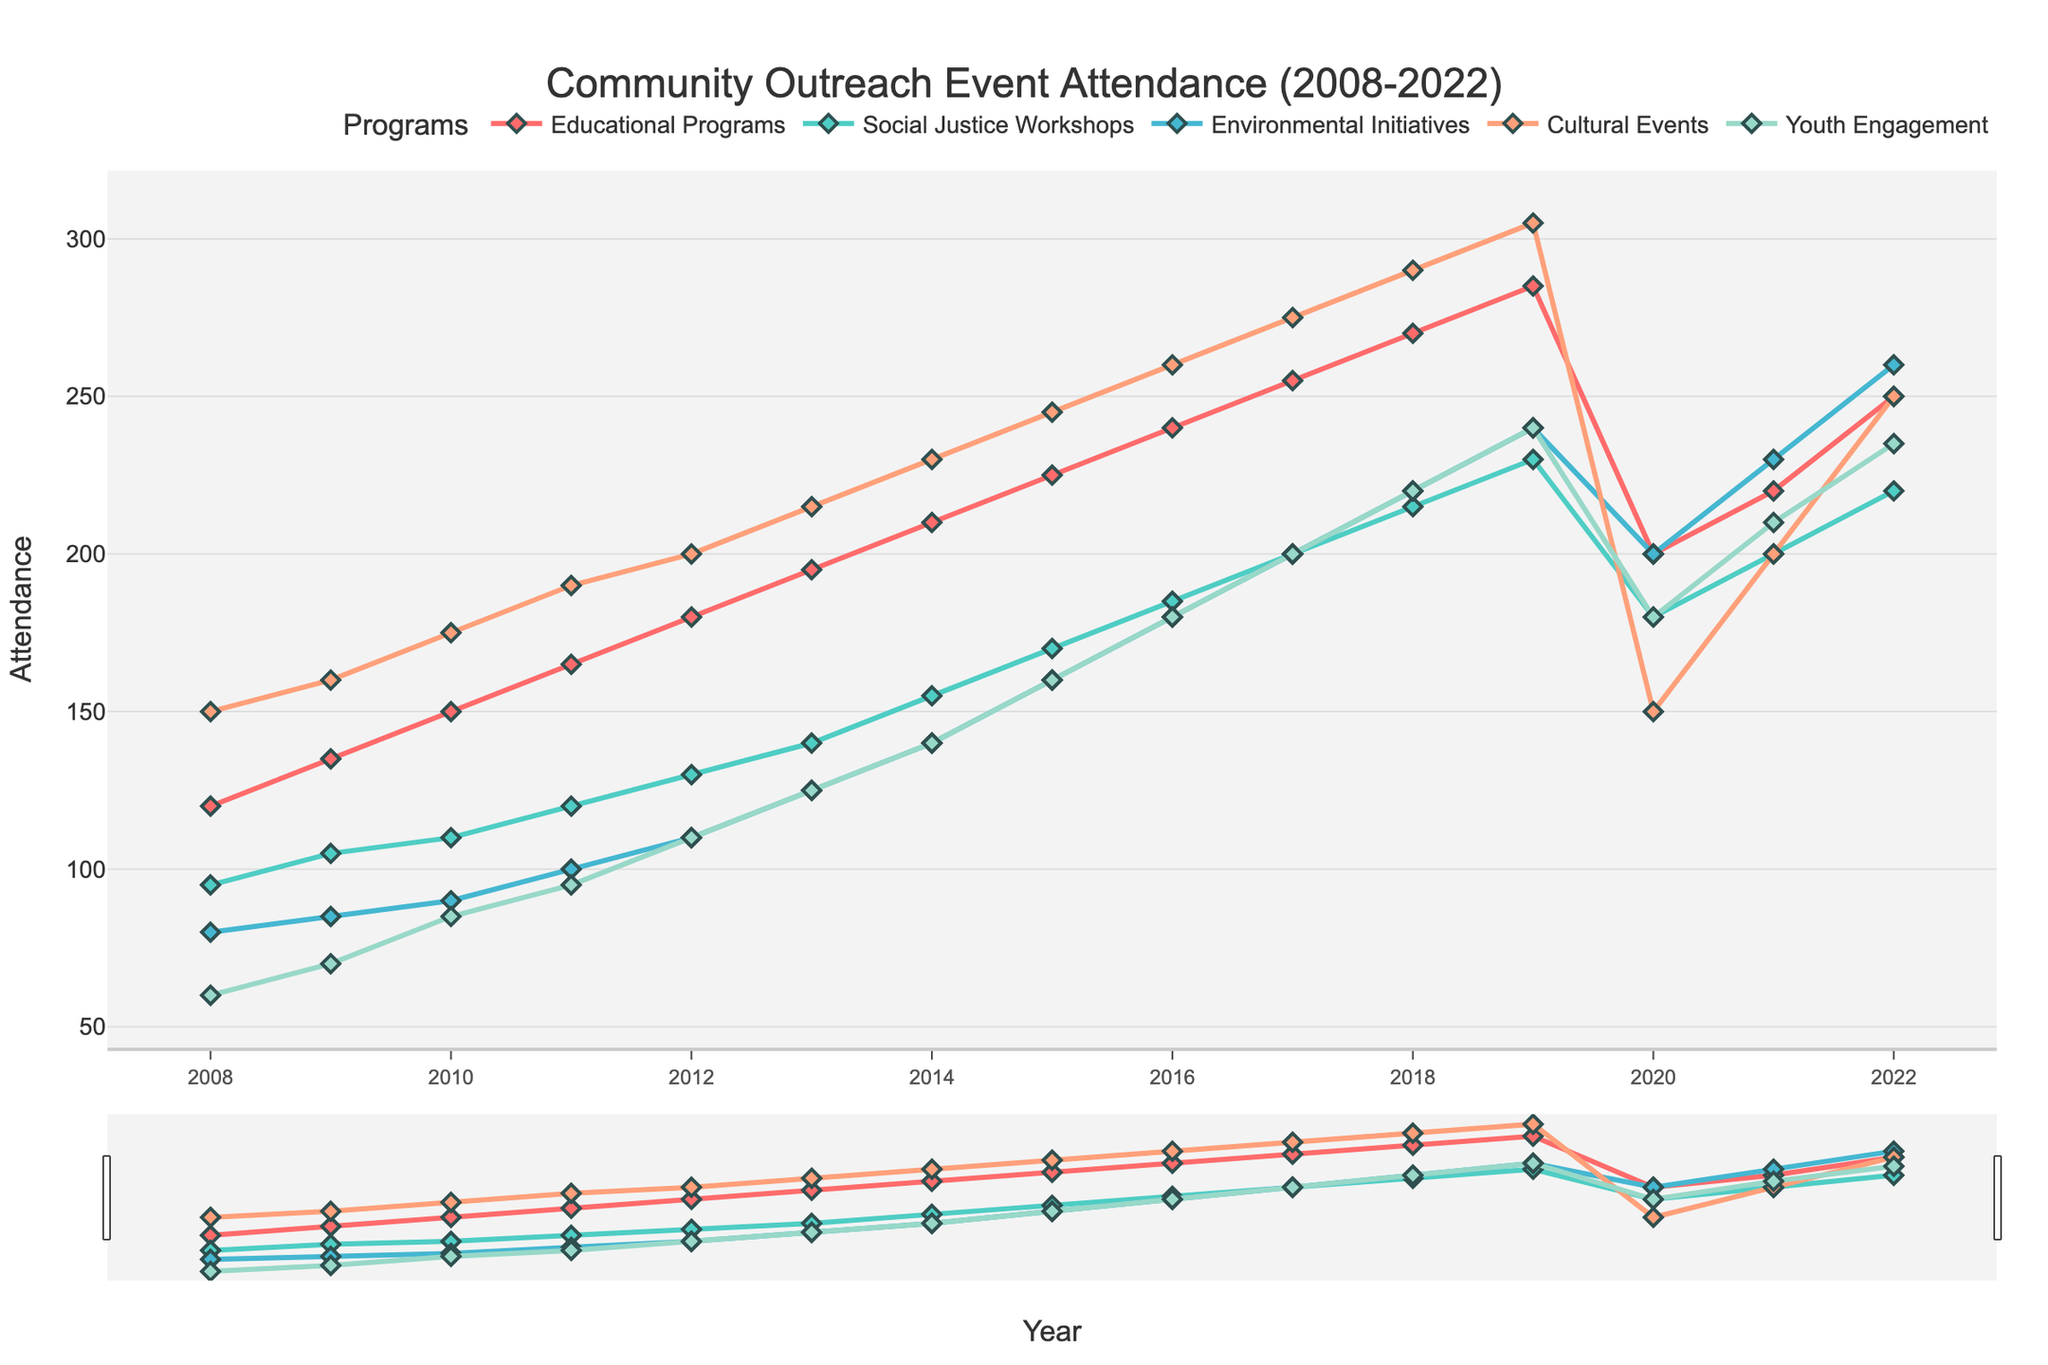Which program had the highest attendance in 2022? In 2022, Cultural Events had the highest attendance rate when compared to other programs. The line representing Cultural Events rises to the highest point on the graph for that year.
Answer: Cultural Events How did attendance for 'Environmental Initiatives' change from 2019 to 2020? The graph shows that the attendance for Environmental Initiatives dropped from 240 in 2019 to 200 in 2020. This can be observed by comparing the heights of the markers in the graph between these two years.
Answer: Decreased Between which consecutive years did 'Youth Engagement' see the highest increase in attendance? By examining the line trend for Youth Engagement, the highest increase in attendance occurs between 2021 and 2022, where the line shows a significant upward spike from 210 to 235.
Answer: 2021 to 2022 What was the average attendance for 'Social Justice Workshops' over the first five years? The first five years encompass 2008 to 2012. The attendances are 95, 105, 110, 120, and 130. The average is calculated as (95+105+110+120+130)/5 = 112.
Answer: 112 Which year had the lowest overall attendance for all programs combined? By comparing the sum of all attendance figures for each year, 2020 has the lowest combined attendance due to the visible drops across almost all programs that year.
Answer: 2020 Was there any program with an attendance decline from 2021 to 2022? Observing the lines for all programs from 2021 to 2022, none of the programs show a decline; all either increased or stayed the same.
Answer: No What is the combined attendance of Cultural Events and Educational Programs in 2015? The attendance for Cultural Events in 2015 is 245 and for Educational Programs is 225. Their combined attendance is 245 + 225 = 470.
Answer: 470 How does the attendance trend for 'Educational Programs' compare to 'Social Justice Workshops' in the first 10 years? From 2008 to 2017, both programs show a consistent upward trend, but Educational Programs generally show a steeper increase in attendance compared to Social Justice Workshops, particularly visible in the higher peaks each year.
Answer: Steeper increase Identify the year when 'Cultural Events' and 'Youth Engagement' had equal attendance. From inspecting the graph, both Cultural Events and Youth Engagement had equal attendance in the year 2020, both recorded at 150.
Answer: 2020 What was the median attendance rate for 'Environmental Initiatives' over the whole period? Listing the attendance values for Environmental Initiatives (80, 85, 90, 100, 110, 125, 140, 160, 180, 200, 220, 240, 200, 230, 260) and finding the middle value, the median attendance is 140.
Answer: 140 